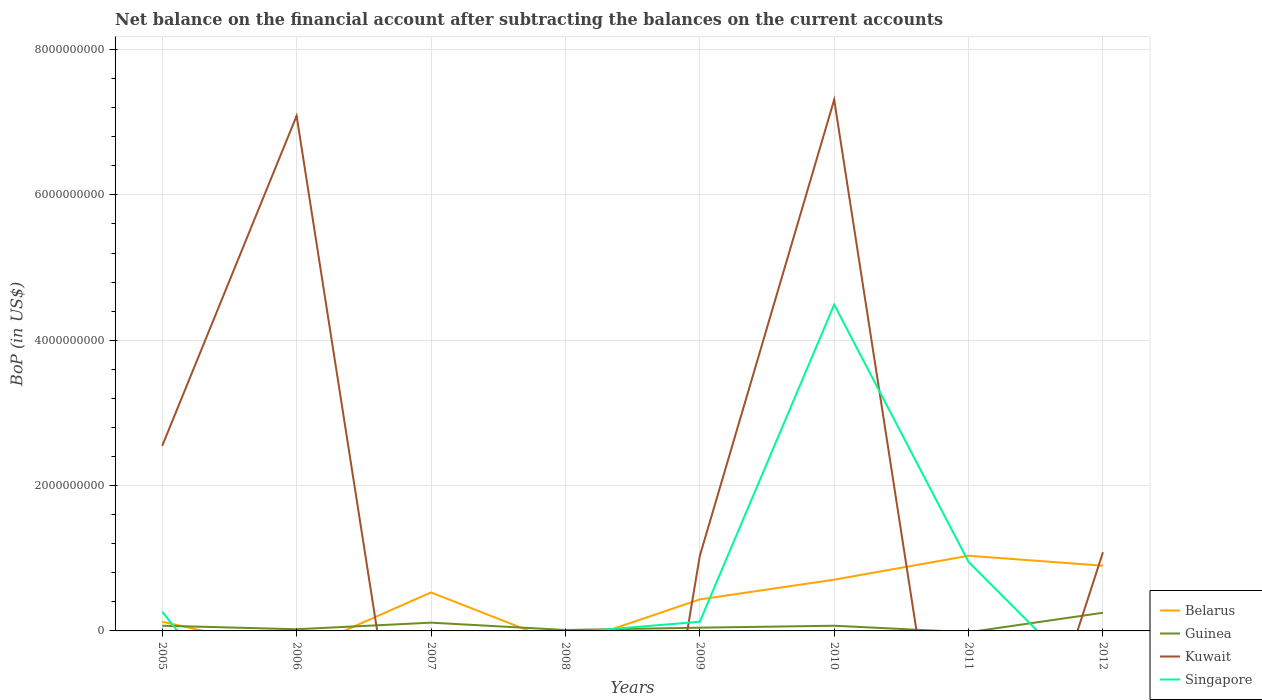How many different coloured lines are there?
Your answer should be very brief. 4. Does the line corresponding to Kuwait intersect with the line corresponding to Belarus?
Ensure brevity in your answer.  Yes. Is the number of lines equal to the number of legend labels?
Make the answer very short. No. Across all years, what is the maximum Balance of Payments in Kuwait?
Keep it short and to the point. 0. What is the total Balance of Payments in Singapore in the graph?
Provide a short and direct response. -4.36e+09. What is the difference between the highest and the second highest Balance of Payments in Guinea?
Provide a short and direct response. 2.50e+08. What is the difference between the highest and the lowest Balance of Payments in Kuwait?
Make the answer very short. 3. Is the Balance of Payments in Belarus strictly greater than the Balance of Payments in Kuwait over the years?
Offer a very short reply. No. How many lines are there?
Offer a terse response. 4. How many years are there in the graph?
Keep it short and to the point. 8. Are the values on the major ticks of Y-axis written in scientific E-notation?
Ensure brevity in your answer.  No. Does the graph contain any zero values?
Provide a short and direct response. Yes. How are the legend labels stacked?
Make the answer very short. Vertical. What is the title of the graph?
Provide a short and direct response. Net balance on the financial account after subtracting the balances on the current accounts. Does "China" appear as one of the legend labels in the graph?
Your answer should be compact. No. What is the label or title of the X-axis?
Offer a very short reply. Years. What is the label or title of the Y-axis?
Provide a short and direct response. BoP (in US$). What is the BoP (in US$) in Belarus in 2005?
Give a very brief answer. 1.27e+08. What is the BoP (in US$) in Guinea in 2005?
Offer a terse response. 7.17e+07. What is the BoP (in US$) in Kuwait in 2005?
Offer a very short reply. 2.55e+09. What is the BoP (in US$) of Singapore in 2005?
Provide a succinct answer. 2.65e+08. What is the BoP (in US$) in Belarus in 2006?
Offer a very short reply. 0. What is the BoP (in US$) in Guinea in 2006?
Offer a very short reply. 2.30e+07. What is the BoP (in US$) of Kuwait in 2006?
Your response must be concise. 7.09e+09. What is the BoP (in US$) in Belarus in 2007?
Provide a succinct answer. 5.29e+08. What is the BoP (in US$) in Guinea in 2007?
Your answer should be very brief. 1.14e+08. What is the BoP (in US$) of Kuwait in 2007?
Offer a terse response. 0. What is the BoP (in US$) of Singapore in 2007?
Ensure brevity in your answer.  0. What is the BoP (in US$) of Guinea in 2008?
Provide a short and direct response. 1.27e+07. What is the BoP (in US$) of Kuwait in 2008?
Keep it short and to the point. 0. What is the BoP (in US$) in Belarus in 2009?
Keep it short and to the point. 4.34e+08. What is the BoP (in US$) in Guinea in 2009?
Your answer should be very brief. 4.48e+07. What is the BoP (in US$) of Kuwait in 2009?
Your answer should be compact. 1.03e+09. What is the BoP (in US$) of Singapore in 2009?
Offer a terse response. 1.27e+08. What is the BoP (in US$) of Belarus in 2010?
Provide a short and direct response. 7.05e+08. What is the BoP (in US$) in Guinea in 2010?
Ensure brevity in your answer.  7.13e+07. What is the BoP (in US$) in Kuwait in 2010?
Provide a short and direct response. 7.31e+09. What is the BoP (in US$) in Singapore in 2010?
Ensure brevity in your answer.  4.49e+09. What is the BoP (in US$) in Belarus in 2011?
Provide a succinct answer. 1.03e+09. What is the BoP (in US$) in Kuwait in 2011?
Provide a succinct answer. 0. What is the BoP (in US$) of Singapore in 2011?
Ensure brevity in your answer.  9.49e+08. What is the BoP (in US$) in Belarus in 2012?
Your answer should be compact. 8.97e+08. What is the BoP (in US$) in Guinea in 2012?
Make the answer very short. 2.50e+08. What is the BoP (in US$) in Kuwait in 2012?
Your answer should be very brief. 1.08e+09. Across all years, what is the maximum BoP (in US$) of Belarus?
Give a very brief answer. 1.03e+09. Across all years, what is the maximum BoP (in US$) in Guinea?
Offer a terse response. 2.50e+08. Across all years, what is the maximum BoP (in US$) of Kuwait?
Offer a terse response. 7.31e+09. Across all years, what is the maximum BoP (in US$) of Singapore?
Offer a terse response. 4.49e+09. Across all years, what is the minimum BoP (in US$) in Belarus?
Provide a succinct answer. 0. Across all years, what is the minimum BoP (in US$) of Guinea?
Ensure brevity in your answer.  0. Across all years, what is the minimum BoP (in US$) in Singapore?
Keep it short and to the point. 0. What is the total BoP (in US$) of Belarus in the graph?
Make the answer very short. 3.73e+09. What is the total BoP (in US$) in Guinea in the graph?
Your answer should be compact. 5.87e+08. What is the total BoP (in US$) in Kuwait in the graph?
Keep it short and to the point. 1.91e+1. What is the total BoP (in US$) of Singapore in the graph?
Your answer should be compact. 5.83e+09. What is the difference between the BoP (in US$) in Guinea in 2005 and that in 2006?
Your answer should be compact. 4.87e+07. What is the difference between the BoP (in US$) in Kuwait in 2005 and that in 2006?
Provide a succinct answer. -4.54e+09. What is the difference between the BoP (in US$) in Belarus in 2005 and that in 2007?
Keep it short and to the point. -4.03e+08. What is the difference between the BoP (in US$) of Guinea in 2005 and that in 2007?
Provide a succinct answer. -4.22e+07. What is the difference between the BoP (in US$) in Guinea in 2005 and that in 2008?
Give a very brief answer. 5.89e+07. What is the difference between the BoP (in US$) in Belarus in 2005 and that in 2009?
Ensure brevity in your answer.  -3.07e+08. What is the difference between the BoP (in US$) of Guinea in 2005 and that in 2009?
Provide a succinct answer. 2.69e+07. What is the difference between the BoP (in US$) of Kuwait in 2005 and that in 2009?
Offer a very short reply. 1.51e+09. What is the difference between the BoP (in US$) of Singapore in 2005 and that in 2009?
Give a very brief answer. 1.38e+08. What is the difference between the BoP (in US$) of Belarus in 2005 and that in 2010?
Offer a very short reply. -5.78e+08. What is the difference between the BoP (in US$) of Guinea in 2005 and that in 2010?
Offer a terse response. 3.80e+05. What is the difference between the BoP (in US$) of Kuwait in 2005 and that in 2010?
Your answer should be very brief. -4.76e+09. What is the difference between the BoP (in US$) of Singapore in 2005 and that in 2010?
Provide a succinct answer. -4.23e+09. What is the difference between the BoP (in US$) in Belarus in 2005 and that in 2011?
Your response must be concise. -9.08e+08. What is the difference between the BoP (in US$) in Singapore in 2005 and that in 2011?
Offer a terse response. -6.84e+08. What is the difference between the BoP (in US$) of Belarus in 2005 and that in 2012?
Your response must be concise. -7.71e+08. What is the difference between the BoP (in US$) in Guinea in 2005 and that in 2012?
Give a very brief answer. -1.78e+08. What is the difference between the BoP (in US$) of Kuwait in 2005 and that in 2012?
Give a very brief answer. 1.46e+09. What is the difference between the BoP (in US$) in Guinea in 2006 and that in 2007?
Keep it short and to the point. -9.09e+07. What is the difference between the BoP (in US$) in Guinea in 2006 and that in 2008?
Your answer should be very brief. 1.02e+07. What is the difference between the BoP (in US$) in Guinea in 2006 and that in 2009?
Make the answer very short. -2.19e+07. What is the difference between the BoP (in US$) in Kuwait in 2006 and that in 2009?
Your response must be concise. 6.06e+09. What is the difference between the BoP (in US$) in Guinea in 2006 and that in 2010?
Provide a short and direct response. -4.83e+07. What is the difference between the BoP (in US$) of Kuwait in 2006 and that in 2010?
Your response must be concise. -2.23e+08. What is the difference between the BoP (in US$) of Guinea in 2006 and that in 2012?
Offer a terse response. -2.27e+08. What is the difference between the BoP (in US$) in Kuwait in 2006 and that in 2012?
Your response must be concise. 6.00e+09. What is the difference between the BoP (in US$) of Guinea in 2007 and that in 2008?
Ensure brevity in your answer.  1.01e+08. What is the difference between the BoP (in US$) in Belarus in 2007 and that in 2009?
Provide a succinct answer. 9.58e+07. What is the difference between the BoP (in US$) of Guinea in 2007 and that in 2009?
Your response must be concise. 6.90e+07. What is the difference between the BoP (in US$) of Belarus in 2007 and that in 2010?
Offer a very short reply. -1.76e+08. What is the difference between the BoP (in US$) in Guinea in 2007 and that in 2010?
Ensure brevity in your answer.  4.25e+07. What is the difference between the BoP (in US$) in Belarus in 2007 and that in 2011?
Offer a terse response. -5.05e+08. What is the difference between the BoP (in US$) of Belarus in 2007 and that in 2012?
Your answer should be compact. -3.68e+08. What is the difference between the BoP (in US$) of Guinea in 2007 and that in 2012?
Provide a short and direct response. -1.36e+08. What is the difference between the BoP (in US$) in Guinea in 2008 and that in 2009?
Provide a short and direct response. -3.21e+07. What is the difference between the BoP (in US$) in Guinea in 2008 and that in 2010?
Ensure brevity in your answer.  -5.86e+07. What is the difference between the BoP (in US$) in Guinea in 2008 and that in 2012?
Offer a terse response. -2.37e+08. What is the difference between the BoP (in US$) in Belarus in 2009 and that in 2010?
Ensure brevity in your answer.  -2.72e+08. What is the difference between the BoP (in US$) of Guinea in 2009 and that in 2010?
Your answer should be very brief. -2.65e+07. What is the difference between the BoP (in US$) in Kuwait in 2009 and that in 2010?
Offer a terse response. -6.28e+09. What is the difference between the BoP (in US$) in Singapore in 2009 and that in 2010?
Your response must be concise. -4.36e+09. What is the difference between the BoP (in US$) in Belarus in 2009 and that in 2011?
Ensure brevity in your answer.  -6.01e+08. What is the difference between the BoP (in US$) of Singapore in 2009 and that in 2011?
Give a very brief answer. -8.23e+08. What is the difference between the BoP (in US$) in Belarus in 2009 and that in 2012?
Offer a very short reply. -4.64e+08. What is the difference between the BoP (in US$) of Guinea in 2009 and that in 2012?
Offer a very short reply. -2.05e+08. What is the difference between the BoP (in US$) of Kuwait in 2009 and that in 2012?
Provide a short and direct response. -5.13e+07. What is the difference between the BoP (in US$) in Belarus in 2010 and that in 2011?
Provide a short and direct response. -3.29e+08. What is the difference between the BoP (in US$) in Singapore in 2010 and that in 2011?
Ensure brevity in your answer.  3.54e+09. What is the difference between the BoP (in US$) of Belarus in 2010 and that in 2012?
Ensure brevity in your answer.  -1.92e+08. What is the difference between the BoP (in US$) in Guinea in 2010 and that in 2012?
Offer a terse response. -1.79e+08. What is the difference between the BoP (in US$) of Kuwait in 2010 and that in 2012?
Your response must be concise. 6.23e+09. What is the difference between the BoP (in US$) of Belarus in 2011 and that in 2012?
Offer a terse response. 1.37e+08. What is the difference between the BoP (in US$) of Belarus in 2005 and the BoP (in US$) of Guinea in 2006?
Offer a very short reply. 1.04e+08. What is the difference between the BoP (in US$) of Belarus in 2005 and the BoP (in US$) of Kuwait in 2006?
Provide a short and direct response. -6.96e+09. What is the difference between the BoP (in US$) of Guinea in 2005 and the BoP (in US$) of Kuwait in 2006?
Provide a short and direct response. -7.02e+09. What is the difference between the BoP (in US$) of Belarus in 2005 and the BoP (in US$) of Guinea in 2007?
Give a very brief answer. 1.28e+07. What is the difference between the BoP (in US$) in Belarus in 2005 and the BoP (in US$) in Guinea in 2008?
Your response must be concise. 1.14e+08. What is the difference between the BoP (in US$) of Belarus in 2005 and the BoP (in US$) of Guinea in 2009?
Your answer should be compact. 8.18e+07. What is the difference between the BoP (in US$) of Belarus in 2005 and the BoP (in US$) of Kuwait in 2009?
Provide a short and direct response. -9.05e+08. What is the difference between the BoP (in US$) of Belarus in 2005 and the BoP (in US$) of Singapore in 2009?
Your answer should be very brief. 2.86e+04. What is the difference between the BoP (in US$) in Guinea in 2005 and the BoP (in US$) in Kuwait in 2009?
Provide a short and direct response. -9.60e+08. What is the difference between the BoP (in US$) of Guinea in 2005 and the BoP (in US$) of Singapore in 2009?
Your answer should be compact. -5.49e+07. What is the difference between the BoP (in US$) of Kuwait in 2005 and the BoP (in US$) of Singapore in 2009?
Provide a succinct answer. 2.42e+09. What is the difference between the BoP (in US$) of Belarus in 2005 and the BoP (in US$) of Guinea in 2010?
Your answer should be very brief. 5.53e+07. What is the difference between the BoP (in US$) in Belarus in 2005 and the BoP (in US$) in Kuwait in 2010?
Your answer should be very brief. -7.18e+09. What is the difference between the BoP (in US$) in Belarus in 2005 and the BoP (in US$) in Singapore in 2010?
Provide a short and direct response. -4.36e+09. What is the difference between the BoP (in US$) in Guinea in 2005 and the BoP (in US$) in Kuwait in 2010?
Offer a very short reply. -7.24e+09. What is the difference between the BoP (in US$) in Guinea in 2005 and the BoP (in US$) in Singapore in 2010?
Give a very brief answer. -4.42e+09. What is the difference between the BoP (in US$) of Kuwait in 2005 and the BoP (in US$) of Singapore in 2010?
Provide a succinct answer. -1.94e+09. What is the difference between the BoP (in US$) of Belarus in 2005 and the BoP (in US$) of Singapore in 2011?
Your answer should be very brief. -8.23e+08. What is the difference between the BoP (in US$) in Guinea in 2005 and the BoP (in US$) in Singapore in 2011?
Your answer should be compact. -8.78e+08. What is the difference between the BoP (in US$) of Kuwait in 2005 and the BoP (in US$) of Singapore in 2011?
Ensure brevity in your answer.  1.60e+09. What is the difference between the BoP (in US$) of Belarus in 2005 and the BoP (in US$) of Guinea in 2012?
Provide a short and direct response. -1.23e+08. What is the difference between the BoP (in US$) of Belarus in 2005 and the BoP (in US$) of Kuwait in 2012?
Make the answer very short. -9.56e+08. What is the difference between the BoP (in US$) of Guinea in 2005 and the BoP (in US$) of Kuwait in 2012?
Give a very brief answer. -1.01e+09. What is the difference between the BoP (in US$) of Guinea in 2006 and the BoP (in US$) of Kuwait in 2009?
Provide a succinct answer. -1.01e+09. What is the difference between the BoP (in US$) in Guinea in 2006 and the BoP (in US$) in Singapore in 2009?
Offer a very short reply. -1.04e+08. What is the difference between the BoP (in US$) in Kuwait in 2006 and the BoP (in US$) in Singapore in 2009?
Provide a short and direct response. 6.96e+09. What is the difference between the BoP (in US$) in Guinea in 2006 and the BoP (in US$) in Kuwait in 2010?
Offer a terse response. -7.29e+09. What is the difference between the BoP (in US$) in Guinea in 2006 and the BoP (in US$) in Singapore in 2010?
Make the answer very short. -4.47e+09. What is the difference between the BoP (in US$) in Kuwait in 2006 and the BoP (in US$) in Singapore in 2010?
Keep it short and to the point. 2.60e+09. What is the difference between the BoP (in US$) of Guinea in 2006 and the BoP (in US$) of Singapore in 2011?
Provide a short and direct response. -9.26e+08. What is the difference between the BoP (in US$) in Kuwait in 2006 and the BoP (in US$) in Singapore in 2011?
Provide a succinct answer. 6.14e+09. What is the difference between the BoP (in US$) in Guinea in 2006 and the BoP (in US$) in Kuwait in 2012?
Your answer should be compact. -1.06e+09. What is the difference between the BoP (in US$) in Belarus in 2007 and the BoP (in US$) in Guinea in 2008?
Make the answer very short. 5.17e+08. What is the difference between the BoP (in US$) in Belarus in 2007 and the BoP (in US$) in Guinea in 2009?
Offer a very short reply. 4.85e+08. What is the difference between the BoP (in US$) in Belarus in 2007 and the BoP (in US$) in Kuwait in 2009?
Keep it short and to the point. -5.02e+08. What is the difference between the BoP (in US$) in Belarus in 2007 and the BoP (in US$) in Singapore in 2009?
Your answer should be very brief. 4.03e+08. What is the difference between the BoP (in US$) of Guinea in 2007 and the BoP (in US$) of Kuwait in 2009?
Ensure brevity in your answer.  -9.18e+08. What is the difference between the BoP (in US$) in Guinea in 2007 and the BoP (in US$) in Singapore in 2009?
Your answer should be very brief. -1.28e+07. What is the difference between the BoP (in US$) in Belarus in 2007 and the BoP (in US$) in Guinea in 2010?
Provide a short and direct response. 4.58e+08. What is the difference between the BoP (in US$) in Belarus in 2007 and the BoP (in US$) in Kuwait in 2010?
Give a very brief answer. -6.78e+09. What is the difference between the BoP (in US$) of Belarus in 2007 and the BoP (in US$) of Singapore in 2010?
Give a very brief answer. -3.96e+09. What is the difference between the BoP (in US$) of Guinea in 2007 and the BoP (in US$) of Kuwait in 2010?
Ensure brevity in your answer.  -7.20e+09. What is the difference between the BoP (in US$) of Guinea in 2007 and the BoP (in US$) of Singapore in 2010?
Provide a short and direct response. -4.38e+09. What is the difference between the BoP (in US$) of Belarus in 2007 and the BoP (in US$) of Singapore in 2011?
Provide a succinct answer. -4.20e+08. What is the difference between the BoP (in US$) in Guinea in 2007 and the BoP (in US$) in Singapore in 2011?
Keep it short and to the point. -8.35e+08. What is the difference between the BoP (in US$) in Belarus in 2007 and the BoP (in US$) in Guinea in 2012?
Give a very brief answer. 2.79e+08. What is the difference between the BoP (in US$) in Belarus in 2007 and the BoP (in US$) in Kuwait in 2012?
Your answer should be compact. -5.53e+08. What is the difference between the BoP (in US$) of Guinea in 2007 and the BoP (in US$) of Kuwait in 2012?
Offer a terse response. -9.69e+08. What is the difference between the BoP (in US$) of Guinea in 2008 and the BoP (in US$) of Kuwait in 2009?
Provide a short and direct response. -1.02e+09. What is the difference between the BoP (in US$) in Guinea in 2008 and the BoP (in US$) in Singapore in 2009?
Provide a short and direct response. -1.14e+08. What is the difference between the BoP (in US$) of Guinea in 2008 and the BoP (in US$) of Kuwait in 2010?
Offer a very short reply. -7.30e+09. What is the difference between the BoP (in US$) of Guinea in 2008 and the BoP (in US$) of Singapore in 2010?
Ensure brevity in your answer.  -4.48e+09. What is the difference between the BoP (in US$) of Guinea in 2008 and the BoP (in US$) of Singapore in 2011?
Provide a short and direct response. -9.36e+08. What is the difference between the BoP (in US$) in Guinea in 2008 and the BoP (in US$) in Kuwait in 2012?
Ensure brevity in your answer.  -1.07e+09. What is the difference between the BoP (in US$) in Belarus in 2009 and the BoP (in US$) in Guinea in 2010?
Keep it short and to the point. 3.62e+08. What is the difference between the BoP (in US$) of Belarus in 2009 and the BoP (in US$) of Kuwait in 2010?
Your response must be concise. -6.88e+09. What is the difference between the BoP (in US$) in Belarus in 2009 and the BoP (in US$) in Singapore in 2010?
Give a very brief answer. -4.06e+09. What is the difference between the BoP (in US$) in Guinea in 2009 and the BoP (in US$) in Kuwait in 2010?
Give a very brief answer. -7.27e+09. What is the difference between the BoP (in US$) of Guinea in 2009 and the BoP (in US$) of Singapore in 2010?
Provide a short and direct response. -4.45e+09. What is the difference between the BoP (in US$) of Kuwait in 2009 and the BoP (in US$) of Singapore in 2010?
Make the answer very short. -3.46e+09. What is the difference between the BoP (in US$) of Belarus in 2009 and the BoP (in US$) of Singapore in 2011?
Offer a very short reply. -5.16e+08. What is the difference between the BoP (in US$) in Guinea in 2009 and the BoP (in US$) in Singapore in 2011?
Offer a very short reply. -9.04e+08. What is the difference between the BoP (in US$) in Kuwait in 2009 and the BoP (in US$) in Singapore in 2011?
Provide a short and direct response. 8.24e+07. What is the difference between the BoP (in US$) of Belarus in 2009 and the BoP (in US$) of Guinea in 2012?
Your answer should be very brief. 1.84e+08. What is the difference between the BoP (in US$) of Belarus in 2009 and the BoP (in US$) of Kuwait in 2012?
Give a very brief answer. -6.49e+08. What is the difference between the BoP (in US$) of Guinea in 2009 and the BoP (in US$) of Kuwait in 2012?
Make the answer very short. -1.04e+09. What is the difference between the BoP (in US$) in Belarus in 2010 and the BoP (in US$) in Singapore in 2011?
Your answer should be very brief. -2.44e+08. What is the difference between the BoP (in US$) in Guinea in 2010 and the BoP (in US$) in Singapore in 2011?
Your answer should be compact. -8.78e+08. What is the difference between the BoP (in US$) of Kuwait in 2010 and the BoP (in US$) of Singapore in 2011?
Ensure brevity in your answer.  6.36e+09. What is the difference between the BoP (in US$) of Belarus in 2010 and the BoP (in US$) of Guinea in 2012?
Your answer should be compact. 4.55e+08. What is the difference between the BoP (in US$) of Belarus in 2010 and the BoP (in US$) of Kuwait in 2012?
Make the answer very short. -3.78e+08. What is the difference between the BoP (in US$) of Guinea in 2010 and the BoP (in US$) of Kuwait in 2012?
Keep it short and to the point. -1.01e+09. What is the difference between the BoP (in US$) in Belarus in 2011 and the BoP (in US$) in Guinea in 2012?
Your response must be concise. 7.84e+08. What is the difference between the BoP (in US$) of Belarus in 2011 and the BoP (in US$) of Kuwait in 2012?
Your answer should be compact. -4.85e+07. What is the average BoP (in US$) in Belarus per year?
Make the answer very short. 4.66e+08. What is the average BoP (in US$) of Guinea per year?
Ensure brevity in your answer.  7.34e+07. What is the average BoP (in US$) in Kuwait per year?
Provide a short and direct response. 2.38e+09. What is the average BoP (in US$) of Singapore per year?
Give a very brief answer. 7.29e+08. In the year 2005, what is the difference between the BoP (in US$) of Belarus and BoP (in US$) of Guinea?
Your answer should be very brief. 5.49e+07. In the year 2005, what is the difference between the BoP (in US$) in Belarus and BoP (in US$) in Kuwait?
Make the answer very short. -2.42e+09. In the year 2005, what is the difference between the BoP (in US$) of Belarus and BoP (in US$) of Singapore?
Make the answer very short. -1.38e+08. In the year 2005, what is the difference between the BoP (in US$) of Guinea and BoP (in US$) of Kuwait?
Offer a terse response. -2.47e+09. In the year 2005, what is the difference between the BoP (in US$) of Guinea and BoP (in US$) of Singapore?
Offer a terse response. -1.93e+08. In the year 2005, what is the difference between the BoP (in US$) of Kuwait and BoP (in US$) of Singapore?
Offer a terse response. 2.28e+09. In the year 2006, what is the difference between the BoP (in US$) in Guinea and BoP (in US$) in Kuwait?
Provide a succinct answer. -7.06e+09. In the year 2007, what is the difference between the BoP (in US$) of Belarus and BoP (in US$) of Guinea?
Give a very brief answer. 4.16e+08. In the year 2009, what is the difference between the BoP (in US$) of Belarus and BoP (in US$) of Guinea?
Provide a succinct answer. 3.89e+08. In the year 2009, what is the difference between the BoP (in US$) of Belarus and BoP (in US$) of Kuwait?
Make the answer very short. -5.98e+08. In the year 2009, what is the difference between the BoP (in US$) in Belarus and BoP (in US$) in Singapore?
Your answer should be very brief. 3.07e+08. In the year 2009, what is the difference between the BoP (in US$) of Guinea and BoP (in US$) of Kuwait?
Give a very brief answer. -9.87e+08. In the year 2009, what is the difference between the BoP (in US$) of Guinea and BoP (in US$) of Singapore?
Provide a succinct answer. -8.18e+07. In the year 2009, what is the difference between the BoP (in US$) of Kuwait and BoP (in US$) of Singapore?
Give a very brief answer. 9.05e+08. In the year 2010, what is the difference between the BoP (in US$) of Belarus and BoP (in US$) of Guinea?
Your answer should be compact. 6.34e+08. In the year 2010, what is the difference between the BoP (in US$) in Belarus and BoP (in US$) in Kuwait?
Provide a succinct answer. -6.60e+09. In the year 2010, what is the difference between the BoP (in US$) of Belarus and BoP (in US$) of Singapore?
Provide a short and direct response. -3.78e+09. In the year 2010, what is the difference between the BoP (in US$) in Guinea and BoP (in US$) in Kuwait?
Offer a terse response. -7.24e+09. In the year 2010, what is the difference between the BoP (in US$) in Guinea and BoP (in US$) in Singapore?
Offer a very short reply. -4.42e+09. In the year 2010, what is the difference between the BoP (in US$) in Kuwait and BoP (in US$) in Singapore?
Provide a succinct answer. 2.82e+09. In the year 2011, what is the difference between the BoP (in US$) in Belarus and BoP (in US$) in Singapore?
Make the answer very short. 8.52e+07. In the year 2012, what is the difference between the BoP (in US$) of Belarus and BoP (in US$) of Guinea?
Make the answer very short. 6.47e+08. In the year 2012, what is the difference between the BoP (in US$) of Belarus and BoP (in US$) of Kuwait?
Provide a succinct answer. -1.86e+08. In the year 2012, what is the difference between the BoP (in US$) of Guinea and BoP (in US$) of Kuwait?
Ensure brevity in your answer.  -8.33e+08. What is the ratio of the BoP (in US$) in Guinea in 2005 to that in 2006?
Provide a succinct answer. 3.12. What is the ratio of the BoP (in US$) of Kuwait in 2005 to that in 2006?
Provide a succinct answer. 0.36. What is the ratio of the BoP (in US$) in Belarus in 2005 to that in 2007?
Provide a short and direct response. 0.24. What is the ratio of the BoP (in US$) in Guinea in 2005 to that in 2007?
Keep it short and to the point. 0.63. What is the ratio of the BoP (in US$) of Guinea in 2005 to that in 2008?
Provide a succinct answer. 5.63. What is the ratio of the BoP (in US$) of Belarus in 2005 to that in 2009?
Ensure brevity in your answer.  0.29. What is the ratio of the BoP (in US$) in Guinea in 2005 to that in 2009?
Provide a short and direct response. 1.6. What is the ratio of the BoP (in US$) in Kuwait in 2005 to that in 2009?
Offer a terse response. 2.47. What is the ratio of the BoP (in US$) in Singapore in 2005 to that in 2009?
Provide a short and direct response. 2.09. What is the ratio of the BoP (in US$) in Belarus in 2005 to that in 2010?
Your answer should be very brief. 0.18. What is the ratio of the BoP (in US$) in Guinea in 2005 to that in 2010?
Your response must be concise. 1.01. What is the ratio of the BoP (in US$) of Kuwait in 2005 to that in 2010?
Keep it short and to the point. 0.35. What is the ratio of the BoP (in US$) of Singapore in 2005 to that in 2010?
Ensure brevity in your answer.  0.06. What is the ratio of the BoP (in US$) of Belarus in 2005 to that in 2011?
Your answer should be compact. 0.12. What is the ratio of the BoP (in US$) of Singapore in 2005 to that in 2011?
Make the answer very short. 0.28. What is the ratio of the BoP (in US$) of Belarus in 2005 to that in 2012?
Give a very brief answer. 0.14. What is the ratio of the BoP (in US$) of Guinea in 2005 to that in 2012?
Your answer should be very brief. 0.29. What is the ratio of the BoP (in US$) in Kuwait in 2005 to that in 2012?
Your response must be concise. 2.35. What is the ratio of the BoP (in US$) of Guinea in 2006 to that in 2007?
Your answer should be very brief. 0.2. What is the ratio of the BoP (in US$) in Guinea in 2006 to that in 2008?
Give a very brief answer. 1.8. What is the ratio of the BoP (in US$) of Guinea in 2006 to that in 2009?
Your answer should be very brief. 0.51. What is the ratio of the BoP (in US$) in Kuwait in 2006 to that in 2009?
Your response must be concise. 6.87. What is the ratio of the BoP (in US$) in Guinea in 2006 to that in 2010?
Give a very brief answer. 0.32. What is the ratio of the BoP (in US$) of Kuwait in 2006 to that in 2010?
Offer a terse response. 0.97. What is the ratio of the BoP (in US$) in Guinea in 2006 to that in 2012?
Give a very brief answer. 0.09. What is the ratio of the BoP (in US$) of Kuwait in 2006 to that in 2012?
Your answer should be very brief. 6.54. What is the ratio of the BoP (in US$) in Guinea in 2007 to that in 2008?
Make the answer very short. 8.94. What is the ratio of the BoP (in US$) of Belarus in 2007 to that in 2009?
Give a very brief answer. 1.22. What is the ratio of the BoP (in US$) in Guinea in 2007 to that in 2009?
Keep it short and to the point. 2.54. What is the ratio of the BoP (in US$) in Belarus in 2007 to that in 2010?
Offer a terse response. 0.75. What is the ratio of the BoP (in US$) in Guinea in 2007 to that in 2010?
Offer a very short reply. 1.6. What is the ratio of the BoP (in US$) in Belarus in 2007 to that in 2011?
Keep it short and to the point. 0.51. What is the ratio of the BoP (in US$) of Belarus in 2007 to that in 2012?
Your response must be concise. 0.59. What is the ratio of the BoP (in US$) in Guinea in 2007 to that in 2012?
Your answer should be compact. 0.46. What is the ratio of the BoP (in US$) in Guinea in 2008 to that in 2009?
Your answer should be compact. 0.28. What is the ratio of the BoP (in US$) of Guinea in 2008 to that in 2010?
Your answer should be compact. 0.18. What is the ratio of the BoP (in US$) of Guinea in 2008 to that in 2012?
Make the answer very short. 0.05. What is the ratio of the BoP (in US$) of Belarus in 2009 to that in 2010?
Provide a short and direct response. 0.61. What is the ratio of the BoP (in US$) of Guinea in 2009 to that in 2010?
Your answer should be compact. 0.63. What is the ratio of the BoP (in US$) of Kuwait in 2009 to that in 2010?
Offer a very short reply. 0.14. What is the ratio of the BoP (in US$) of Singapore in 2009 to that in 2010?
Ensure brevity in your answer.  0.03. What is the ratio of the BoP (in US$) of Belarus in 2009 to that in 2011?
Make the answer very short. 0.42. What is the ratio of the BoP (in US$) in Singapore in 2009 to that in 2011?
Make the answer very short. 0.13. What is the ratio of the BoP (in US$) in Belarus in 2009 to that in 2012?
Offer a very short reply. 0.48. What is the ratio of the BoP (in US$) of Guinea in 2009 to that in 2012?
Keep it short and to the point. 0.18. What is the ratio of the BoP (in US$) of Kuwait in 2009 to that in 2012?
Your response must be concise. 0.95. What is the ratio of the BoP (in US$) of Belarus in 2010 to that in 2011?
Make the answer very short. 0.68. What is the ratio of the BoP (in US$) of Singapore in 2010 to that in 2011?
Provide a short and direct response. 4.73. What is the ratio of the BoP (in US$) in Belarus in 2010 to that in 2012?
Your answer should be compact. 0.79. What is the ratio of the BoP (in US$) in Guinea in 2010 to that in 2012?
Your answer should be very brief. 0.29. What is the ratio of the BoP (in US$) in Kuwait in 2010 to that in 2012?
Provide a succinct answer. 6.75. What is the ratio of the BoP (in US$) in Belarus in 2011 to that in 2012?
Your response must be concise. 1.15. What is the difference between the highest and the second highest BoP (in US$) in Belarus?
Offer a terse response. 1.37e+08. What is the difference between the highest and the second highest BoP (in US$) of Guinea?
Give a very brief answer. 1.36e+08. What is the difference between the highest and the second highest BoP (in US$) of Kuwait?
Make the answer very short. 2.23e+08. What is the difference between the highest and the second highest BoP (in US$) in Singapore?
Keep it short and to the point. 3.54e+09. What is the difference between the highest and the lowest BoP (in US$) in Belarus?
Ensure brevity in your answer.  1.03e+09. What is the difference between the highest and the lowest BoP (in US$) in Guinea?
Your answer should be compact. 2.50e+08. What is the difference between the highest and the lowest BoP (in US$) in Kuwait?
Make the answer very short. 7.31e+09. What is the difference between the highest and the lowest BoP (in US$) of Singapore?
Keep it short and to the point. 4.49e+09. 